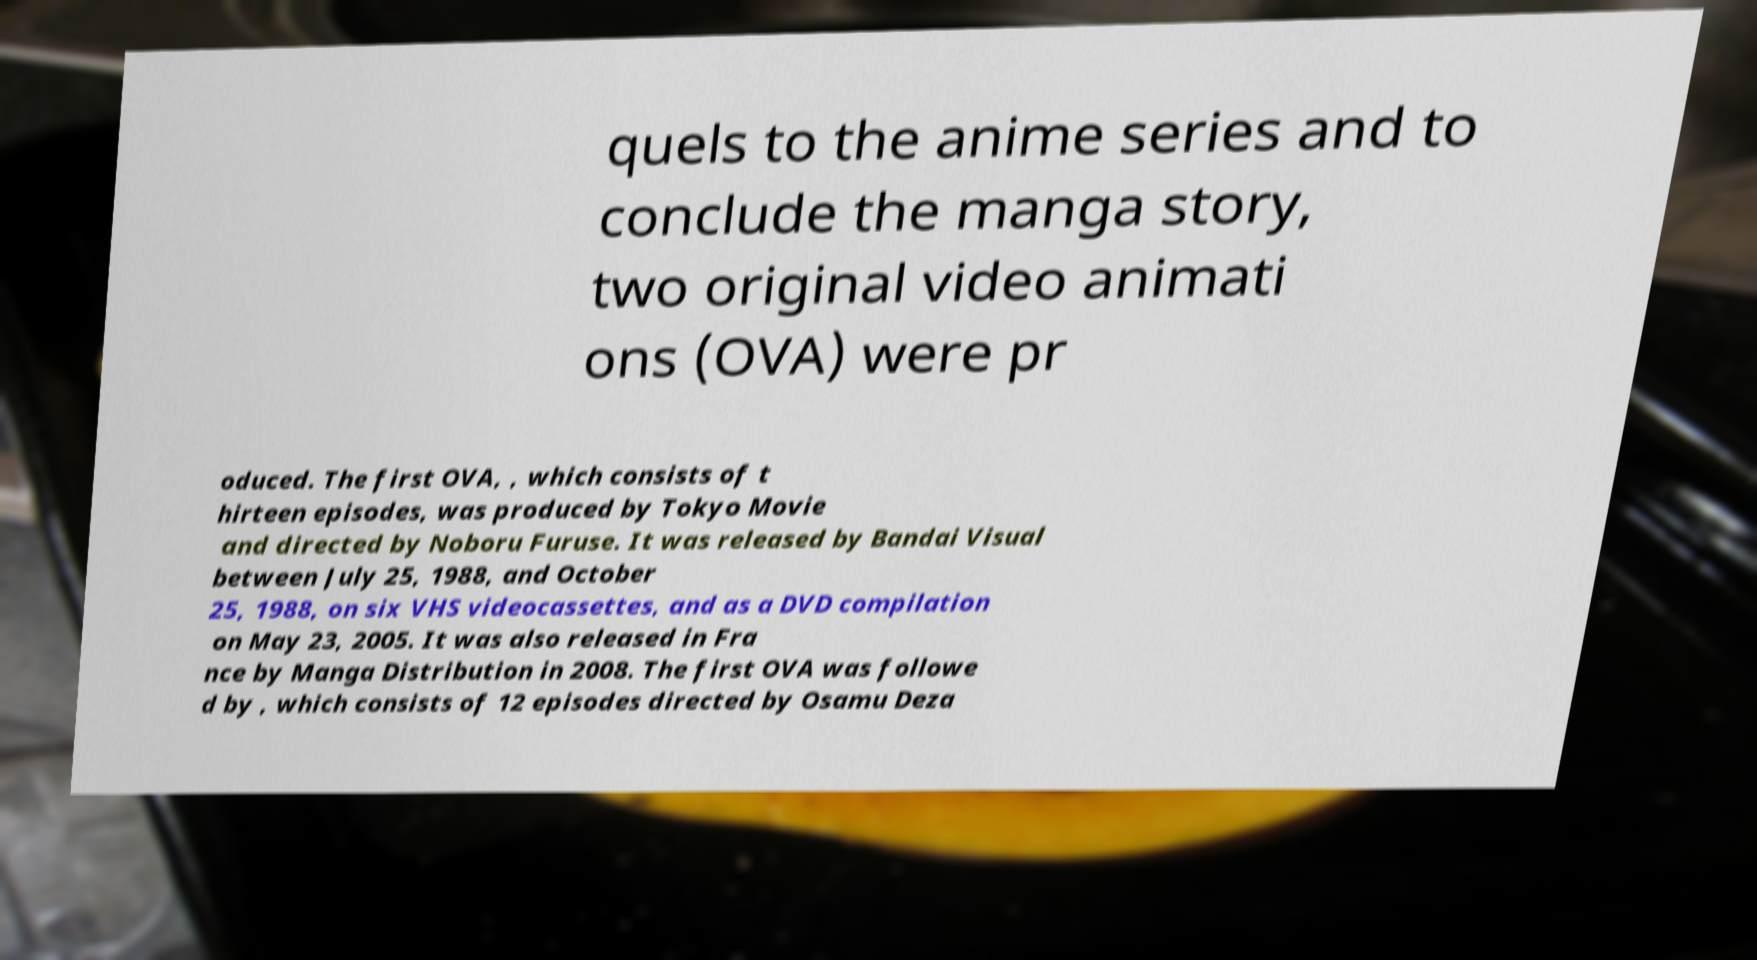Could you assist in decoding the text presented in this image and type it out clearly? quels to the anime series and to conclude the manga story, two original video animati ons (OVA) were pr oduced. The first OVA, , which consists of t hirteen episodes, was produced by Tokyo Movie and directed by Noboru Furuse. It was released by Bandai Visual between July 25, 1988, and October 25, 1988, on six VHS videocassettes, and as a DVD compilation on May 23, 2005. It was also released in Fra nce by Manga Distribution in 2008. The first OVA was followe d by , which consists of 12 episodes directed by Osamu Deza 